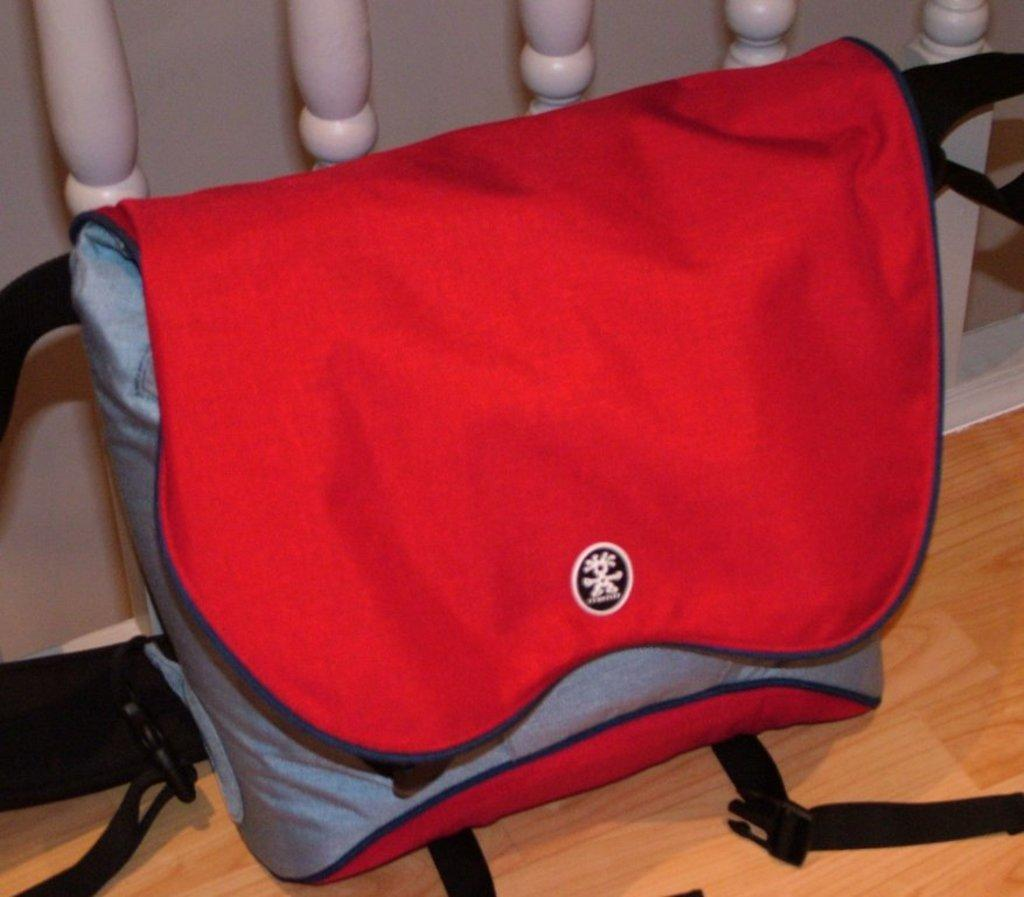What is placed on the wooden surface in the image? There is a bag on a wooden surface in the image. Can you describe the color of the objects in the image? The objects in the image are white-colored. How many eyes can be seen on the bag in the image? There are no eyes visible on the bag in the image. What type of sign is present in the image? There is no sign present in the image; it only features a bag on a wooden surface and white-colored objects. 